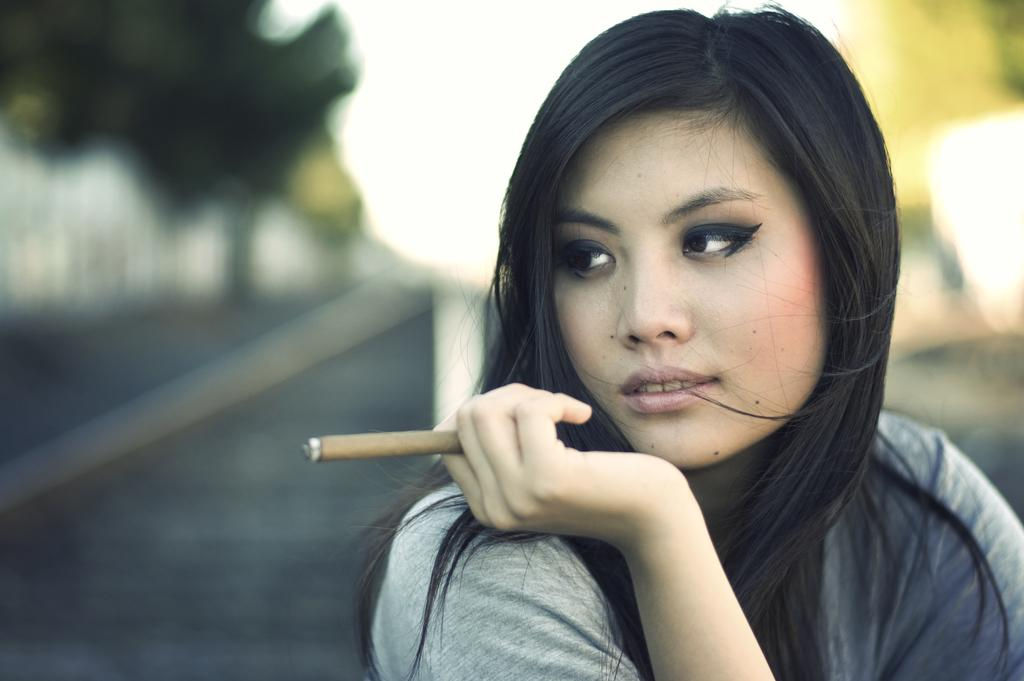What can be seen in the image? There is a person in the image. What is the person doing in the image? The person is holding an object. What is the person wearing in the image? The person is wearing a gray shirt. How would you describe the background of the image? The background of the image is blurred. How does the person's stomach feel in the image? There is no information about the person's stomach in the image, so it cannot be determined how it feels. 